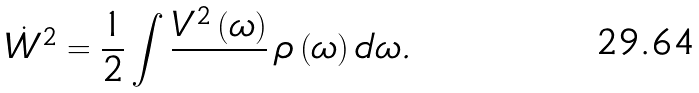<formula> <loc_0><loc_0><loc_500><loc_500>\dot { W } ^ { 2 } = \frac { 1 } { 2 } \int { \frac { V ^ { 2 } \left ( \omega \right ) } { } } \, \rho \left ( \omega \right ) d \omega .</formula> 